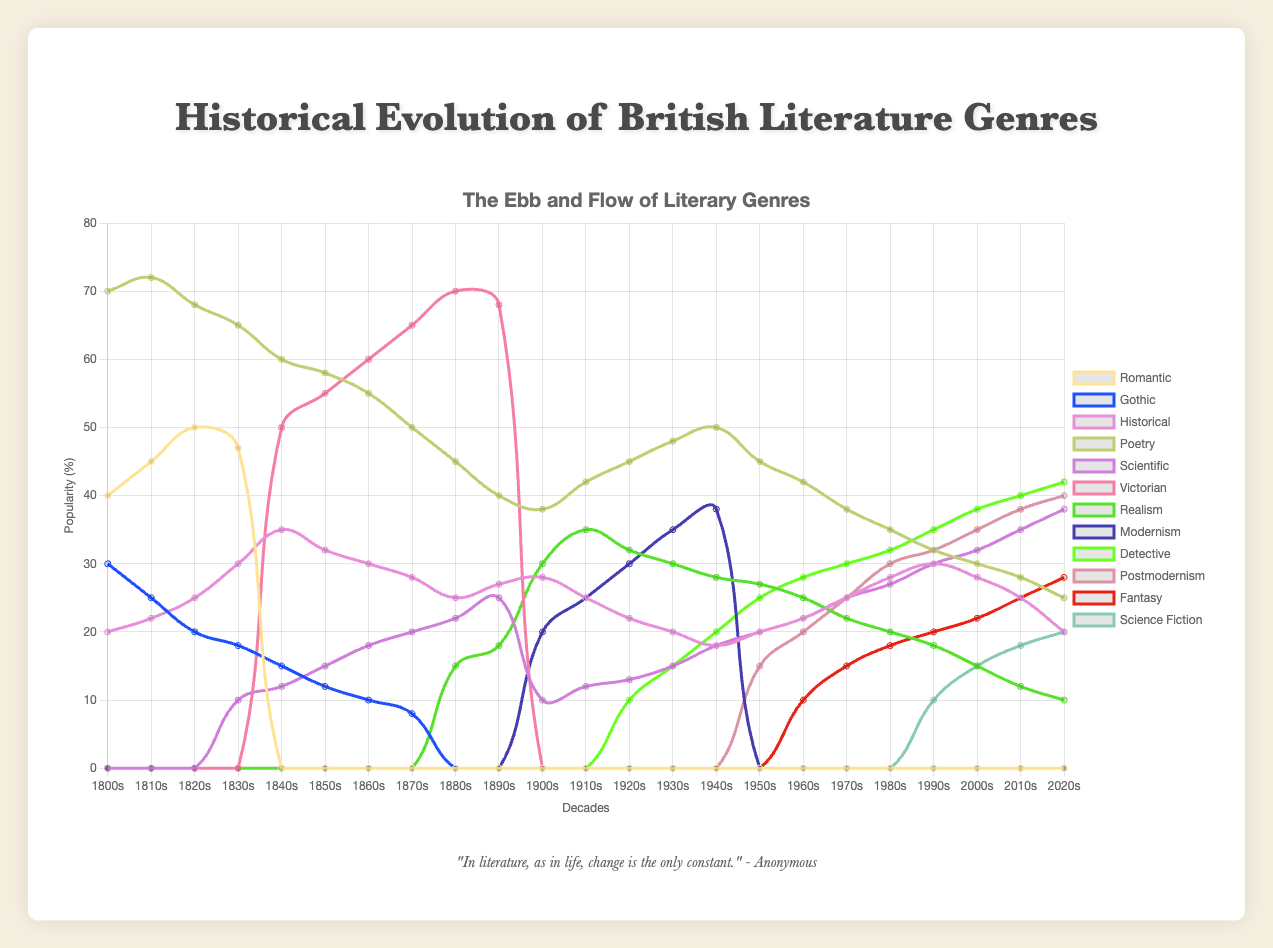Which genre had the highest popularity in the 1800s? The figure shows that in the 1800s, Poetry had the highest popularity with a value of 70.
Answer: Poetry How did the popularity of the Gothic genre change from the 1800s to the 1870s? In the 1800s, Gothic had a popularity of 30, which decreased over the decades to 8 by the 1870s. This shows a continuous decline in its popularity.
Answer: It decreased Which two decades saw the highest and lowest popularity of Modernism? The highest popularity of Modernism can be seen in the 1940s with a value of 38, and the lowest in the 1900s with a value of 20.
Answer: 1940s (highest) and 1900s (lowest) How does the popularity of Scientific literature compare between the 1840s and the 2020s? The popularity of Scientific literature in the 1840s was 12, whereas in the 2020s, it increased significantly to 38.
Answer: It increased What is the range of popularity for the Realism genre from the 1900s to the 2020s? The popularity of Realism goes from 30 in the 1900s to 10 in the 2020s. The range is the difference between the highest and lowest values, i.e., 30 - 10 = 20.
Answer: 20 Calculate the average popularity of the Victorian genre from the 1840s to the 1890s. Popularities: 50 (1840s), 55 (1850s), 60 (1860s), 65 (1870s), 70 (1880s), 68 (1890s). Sum = 368, number of decades = 6, Average = 368 / 6 = 61.33.
Answer: 61.33 Compare the trends of the Poetry genre in the 1800s and the Gothic genre in the 1800s. Poetry has a high and relatively stable popularity in the 1800s (70 to 68), while Gothic sees a declining trend (30 to 20).
Answer: Poetry is stable, Gothic declines What decade marks the introduction of Science Fiction in the dataset? Science Fiction appears for the first time in the 1990s with a value of 10.
Answer: 1990s Determine the decade in which the Gothic genre is closest in popularity to the Postmodernism genre. The Gothic genre in the 1960s has a popularity of 10, closest to the Postmodernism genre in the same decade, which has a popularity of 20.
Answer: 1960s What is the combined popularity of the Detective and Fantasy genres in the 2020s? In the 2020s, Detective has a popularity of 42 and Fantasy has 28. Combined popularity = 42 + 28 = 70.
Answer: 70 